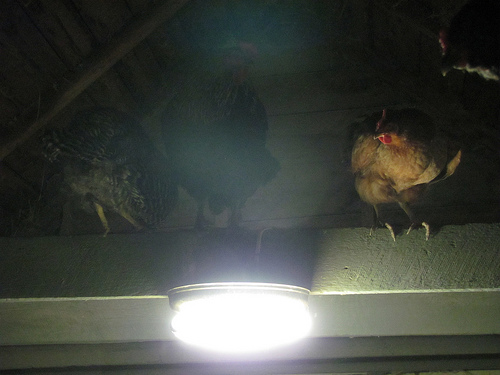<image>
Is the light under the chicken? Yes. The light is positioned underneath the chicken, with the chicken above it in the vertical space. 